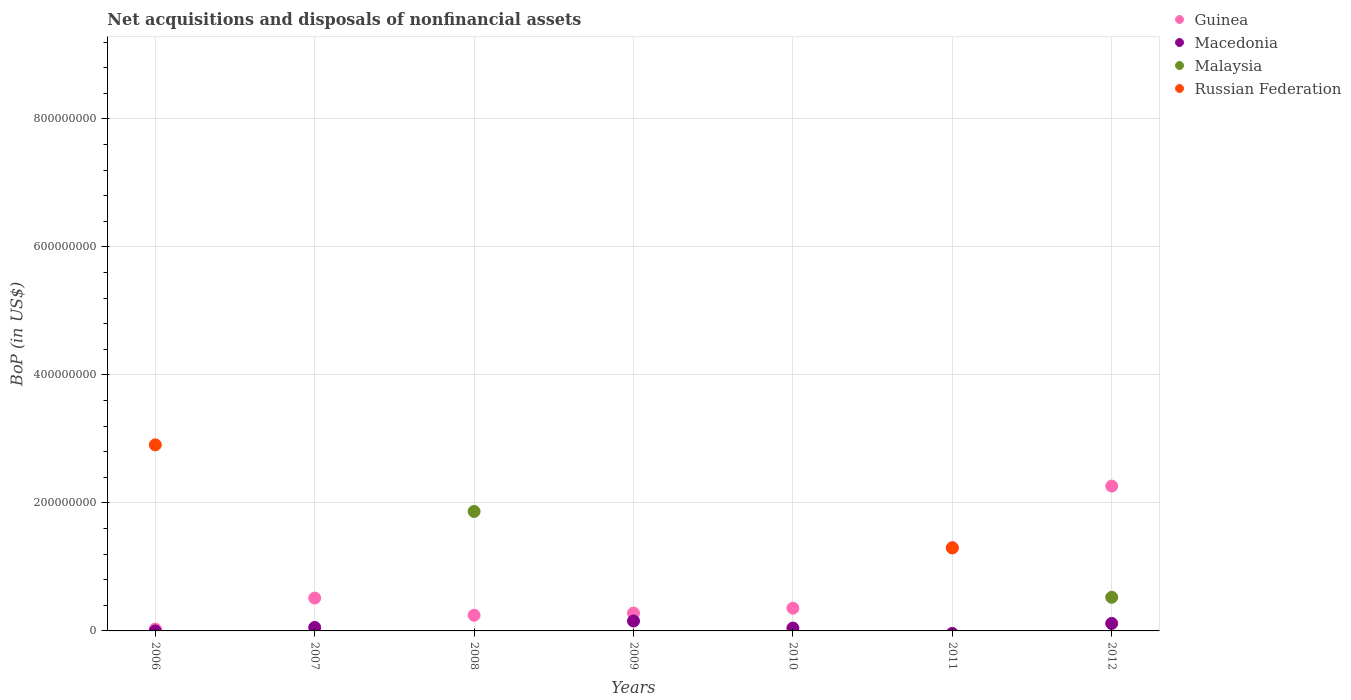How many different coloured dotlines are there?
Give a very brief answer. 4. What is the Balance of Payments in Guinea in 2006?
Your response must be concise. 2.83e+06. Across all years, what is the maximum Balance of Payments in Macedonia?
Make the answer very short. 1.55e+07. Across all years, what is the minimum Balance of Payments in Macedonia?
Offer a terse response. 0. In which year was the Balance of Payments in Macedonia maximum?
Your answer should be compact. 2009. What is the total Balance of Payments in Russian Federation in the graph?
Your answer should be very brief. 4.20e+08. What is the difference between the Balance of Payments in Macedonia in 2009 and that in 2010?
Make the answer very short. 1.10e+07. What is the difference between the Balance of Payments in Russian Federation in 2012 and the Balance of Payments in Guinea in 2008?
Provide a short and direct response. -2.45e+07. What is the average Balance of Payments in Russian Federation per year?
Make the answer very short. 6.01e+07. In the year 2009, what is the difference between the Balance of Payments in Guinea and Balance of Payments in Macedonia?
Your answer should be very brief. 1.24e+07. What is the ratio of the Balance of Payments in Macedonia in 2007 to that in 2010?
Your answer should be very brief. 1.2. Is the Balance of Payments in Guinea in 2006 less than that in 2007?
Ensure brevity in your answer.  Yes. What is the difference between the highest and the second highest Balance of Payments in Macedonia?
Your answer should be compact. 3.81e+06. What is the difference between the highest and the lowest Balance of Payments in Macedonia?
Make the answer very short. 1.55e+07. Is the sum of the Balance of Payments in Guinea in 2007 and 2009 greater than the maximum Balance of Payments in Russian Federation across all years?
Provide a short and direct response. No. Is it the case that in every year, the sum of the Balance of Payments in Russian Federation and Balance of Payments in Macedonia  is greater than the sum of Balance of Payments in Guinea and Balance of Payments in Malaysia?
Offer a terse response. No. Does the Balance of Payments in Guinea monotonically increase over the years?
Your answer should be very brief. No. Is the Balance of Payments in Macedonia strictly greater than the Balance of Payments in Russian Federation over the years?
Offer a very short reply. No. Is the Balance of Payments in Russian Federation strictly less than the Balance of Payments in Malaysia over the years?
Provide a short and direct response. No. Are the values on the major ticks of Y-axis written in scientific E-notation?
Provide a succinct answer. No. Does the graph contain any zero values?
Offer a very short reply. Yes. Does the graph contain grids?
Provide a short and direct response. Yes. Where does the legend appear in the graph?
Give a very brief answer. Top right. How many legend labels are there?
Ensure brevity in your answer.  4. What is the title of the graph?
Make the answer very short. Net acquisitions and disposals of nonfinancial assets. Does "St. Vincent and the Grenadines" appear as one of the legend labels in the graph?
Provide a short and direct response. No. What is the label or title of the Y-axis?
Keep it short and to the point. BoP (in US$). What is the BoP (in US$) of Guinea in 2006?
Your answer should be compact. 2.83e+06. What is the BoP (in US$) of Macedonia in 2006?
Give a very brief answer. 4585.23. What is the BoP (in US$) of Malaysia in 2006?
Ensure brevity in your answer.  0. What is the BoP (in US$) of Russian Federation in 2006?
Give a very brief answer. 2.91e+08. What is the BoP (in US$) of Guinea in 2007?
Your response must be concise. 5.13e+07. What is the BoP (in US$) in Macedonia in 2007?
Offer a very short reply. 5.40e+06. What is the BoP (in US$) of Guinea in 2008?
Offer a terse response. 2.45e+07. What is the BoP (in US$) of Malaysia in 2008?
Offer a very short reply. 1.87e+08. What is the BoP (in US$) of Guinea in 2009?
Make the answer very short. 2.79e+07. What is the BoP (in US$) of Macedonia in 2009?
Offer a terse response. 1.55e+07. What is the BoP (in US$) in Guinea in 2010?
Your answer should be very brief. 3.56e+07. What is the BoP (in US$) of Macedonia in 2010?
Your answer should be compact. 4.49e+06. What is the BoP (in US$) in Malaysia in 2010?
Ensure brevity in your answer.  0. What is the BoP (in US$) in Russian Federation in 2010?
Provide a short and direct response. 0. What is the BoP (in US$) in Guinea in 2011?
Make the answer very short. 1.30e+08. What is the BoP (in US$) in Malaysia in 2011?
Give a very brief answer. 0. What is the BoP (in US$) in Russian Federation in 2011?
Make the answer very short. 1.30e+08. What is the BoP (in US$) in Guinea in 2012?
Your answer should be compact. 2.26e+08. What is the BoP (in US$) of Macedonia in 2012?
Your answer should be compact. 1.17e+07. What is the BoP (in US$) of Malaysia in 2012?
Give a very brief answer. 5.25e+07. What is the BoP (in US$) in Russian Federation in 2012?
Your answer should be very brief. 0. Across all years, what is the maximum BoP (in US$) in Guinea?
Make the answer very short. 2.26e+08. Across all years, what is the maximum BoP (in US$) in Macedonia?
Make the answer very short. 1.55e+07. Across all years, what is the maximum BoP (in US$) in Malaysia?
Keep it short and to the point. 1.87e+08. Across all years, what is the maximum BoP (in US$) of Russian Federation?
Offer a terse response. 2.91e+08. Across all years, what is the minimum BoP (in US$) of Guinea?
Your answer should be compact. 2.83e+06. Across all years, what is the minimum BoP (in US$) of Macedonia?
Your answer should be compact. 0. Across all years, what is the minimum BoP (in US$) of Malaysia?
Make the answer very short. 0. Across all years, what is the minimum BoP (in US$) in Russian Federation?
Offer a terse response. 0. What is the total BoP (in US$) in Guinea in the graph?
Keep it short and to the point. 4.98e+08. What is the total BoP (in US$) in Macedonia in the graph?
Ensure brevity in your answer.  3.71e+07. What is the total BoP (in US$) in Malaysia in the graph?
Ensure brevity in your answer.  2.39e+08. What is the total BoP (in US$) in Russian Federation in the graph?
Provide a succinct answer. 4.20e+08. What is the difference between the BoP (in US$) of Guinea in 2006 and that in 2007?
Offer a very short reply. -4.85e+07. What is the difference between the BoP (in US$) of Macedonia in 2006 and that in 2007?
Your response must be concise. -5.40e+06. What is the difference between the BoP (in US$) of Guinea in 2006 and that in 2008?
Ensure brevity in your answer.  -2.16e+07. What is the difference between the BoP (in US$) in Guinea in 2006 and that in 2009?
Your response must be concise. -2.50e+07. What is the difference between the BoP (in US$) of Macedonia in 2006 and that in 2009?
Make the answer very short. -1.55e+07. What is the difference between the BoP (in US$) in Guinea in 2006 and that in 2010?
Your answer should be compact. -3.27e+07. What is the difference between the BoP (in US$) in Macedonia in 2006 and that in 2010?
Keep it short and to the point. -4.48e+06. What is the difference between the BoP (in US$) of Guinea in 2006 and that in 2011?
Ensure brevity in your answer.  -1.27e+08. What is the difference between the BoP (in US$) in Russian Federation in 2006 and that in 2011?
Your response must be concise. 1.61e+08. What is the difference between the BoP (in US$) in Guinea in 2006 and that in 2012?
Your answer should be compact. -2.23e+08. What is the difference between the BoP (in US$) in Macedonia in 2006 and that in 2012?
Ensure brevity in your answer.  -1.17e+07. What is the difference between the BoP (in US$) in Guinea in 2007 and that in 2008?
Give a very brief answer. 2.68e+07. What is the difference between the BoP (in US$) of Guinea in 2007 and that in 2009?
Offer a terse response. 2.34e+07. What is the difference between the BoP (in US$) of Macedonia in 2007 and that in 2009?
Offer a terse response. -1.01e+07. What is the difference between the BoP (in US$) of Guinea in 2007 and that in 2010?
Provide a short and direct response. 1.58e+07. What is the difference between the BoP (in US$) in Macedonia in 2007 and that in 2010?
Ensure brevity in your answer.  9.14e+05. What is the difference between the BoP (in US$) in Guinea in 2007 and that in 2011?
Your response must be concise. -7.87e+07. What is the difference between the BoP (in US$) in Guinea in 2007 and that in 2012?
Your answer should be compact. -1.75e+08. What is the difference between the BoP (in US$) of Macedonia in 2007 and that in 2012?
Provide a succinct answer. -6.30e+06. What is the difference between the BoP (in US$) of Guinea in 2008 and that in 2009?
Make the answer very short. -3.39e+06. What is the difference between the BoP (in US$) of Guinea in 2008 and that in 2010?
Provide a short and direct response. -1.11e+07. What is the difference between the BoP (in US$) in Guinea in 2008 and that in 2011?
Ensure brevity in your answer.  -1.06e+08. What is the difference between the BoP (in US$) in Guinea in 2008 and that in 2012?
Offer a terse response. -2.02e+08. What is the difference between the BoP (in US$) in Malaysia in 2008 and that in 2012?
Give a very brief answer. 1.34e+08. What is the difference between the BoP (in US$) in Guinea in 2009 and that in 2010?
Make the answer very short. -7.70e+06. What is the difference between the BoP (in US$) in Macedonia in 2009 and that in 2010?
Offer a terse response. 1.10e+07. What is the difference between the BoP (in US$) in Guinea in 2009 and that in 2011?
Offer a terse response. -1.02e+08. What is the difference between the BoP (in US$) of Guinea in 2009 and that in 2012?
Ensure brevity in your answer.  -1.98e+08. What is the difference between the BoP (in US$) in Macedonia in 2009 and that in 2012?
Offer a very short reply. 3.81e+06. What is the difference between the BoP (in US$) in Guinea in 2010 and that in 2011?
Your answer should be compact. -9.45e+07. What is the difference between the BoP (in US$) of Guinea in 2010 and that in 2012?
Offer a very short reply. -1.91e+08. What is the difference between the BoP (in US$) in Macedonia in 2010 and that in 2012?
Give a very brief answer. -7.22e+06. What is the difference between the BoP (in US$) in Guinea in 2011 and that in 2012?
Ensure brevity in your answer.  -9.62e+07. What is the difference between the BoP (in US$) in Guinea in 2006 and the BoP (in US$) in Macedonia in 2007?
Give a very brief answer. -2.57e+06. What is the difference between the BoP (in US$) of Guinea in 2006 and the BoP (in US$) of Malaysia in 2008?
Offer a terse response. -1.84e+08. What is the difference between the BoP (in US$) in Macedonia in 2006 and the BoP (in US$) in Malaysia in 2008?
Your response must be concise. -1.87e+08. What is the difference between the BoP (in US$) in Guinea in 2006 and the BoP (in US$) in Macedonia in 2009?
Your response must be concise. -1.27e+07. What is the difference between the BoP (in US$) in Guinea in 2006 and the BoP (in US$) in Macedonia in 2010?
Give a very brief answer. -1.66e+06. What is the difference between the BoP (in US$) of Guinea in 2006 and the BoP (in US$) of Russian Federation in 2011?
Offer a very short reply. -1.27e+08. What is the difference between the BoP (in US$) of Macedonia in 2006 and the BoP (in US$) of Russian Federation in 2011?
Provide a short and direct response. -1.30e+08. What is the difference between the BoP (in US$) in Guinea in 2006 and the BoP (in US$) in Macedonia in 2012?
Provide a short and direct response. -8.87e+06. What is the difference between the BoP (in US$) of Guinea in 2006 and the BoP (in US$) of Malaysia in 2012?
Your answer should be very brief. -4.97e+07. What is the difference between the BoP (in US$) of Macedonia in 2006 and the BoP (in US$) of Malaysia in 2012?
Give a very brief answer. -5.25e+07. What is the difference between the BoP (in US$) in Guinea in 2007 and the BoP (in US$) in Malaysia in 2008?
Your answer should be compact. -1.35e+08. What is the difference between the BoP (in US$) in Macedonia in 2007 and the BoP (in US$) in Malaysia in 2008?
Provide a short and direct response. -1.81e+08. What is the difference between the BoP (in US$) of Guinea in 2007 and the BoP (in US$) of Macedonia in 2009?
Keep it short and to the point. 3.58e+07. What is the difference between the BoP (in US$) in Guinea in 2007 and the BoP (in US$) in Macedonia in 2010?
Your answer should be compact. 4.68e+07. What is the difference between the BoP (in US$) of Guinea in 2007 and the BoP (in US$) of Russian Federation in 2011?
Provide a short and direct response. -7.84e+07. What is the difference between the BoP (in US$) of Macedonia in 2007 and the BoP (in US$) of Russian Federation in 2011?
Your answer should be compact. -1.24e+08. What is the difference between the BoP (in US$) of Guinea in 2007 and the BoP (in US$) of Macedonia in 2012?
Your answer should be compact. 3.96e+07. What is the difference between the BoP (in US$) of Guinea in 2007 and the BoP (in US$) of Malaysia in 2012?
Offer a very short reply. -1.22e+06. What is the difference between the BoP (in US$) in Macedonia in 2007 and the BoP (in US$) in Malaysia in 2012?
Provide a succinct answer. -4.71e+07. What is the difference between the BoP (in US$) in Guinea in 2008 and the BoP (in US$) in Macedonia in 2009?
Your answer should be very brief. 8.97e+06. What is the difference between the BoP (in US$) of Guinea in 2008 and the BoP (in US$) of Macedonia in 2010?
Provide a short and direct response. 2.00e+07. What is the difference between the BoP (in US$) of Guinea in 2008 and the BoP (in US$) of Russian Federation in 2011?
Give a very brief answer. -1.05e+08. What is the difference between the BoP (in US$) of Malaysia in 2008 and the BoP (in US$) of Russian Federation in 2011?
Offer a terse response. 5.69e+07. What is the difference between the BoP (in US$) in Guinea in 2008 and the BoP (in US$) in Macedonia in 2012?
Provide a succinct answer. 1.28e+07. What is the difference between the BoP (in US$) in Guinea in 2008 and the BoP (in US$) in Malaysia in 2012?
Offer a very short reply. -2.81e+07. What is the difference between the BoP (in US$) in Guinea in 2009 and the BoP (in US$) in Macedonia in 2010?
Your response must be concise. 2.34e+07. What is the difference between the BoP (in US$) in Guinea in 2009 and the BoP (in US$) in Russian Federation in 2011?
Your answer should be compact. -1.02e+08. What is the difference between the BoP (in US$) in Macedonia in 2009 and the BoP (in US$) in Russian Federation in 2011?
Make the answer very short. -1.14e+08. What is the difference between the BoP (in US$) of Guinea in 2009 and the BoP (in US$) of Macedonia in 2012?
Your answer should be very brief. 1.62e+07. What is the difference between the BoP (in US$) of Guinea in 2009 and the BoP (in US$) of Malaysia in 2012?
Offer a terse response. -2.47e+07. What is the difference between the BoP (in US$) in Macedonia in 2009 and the BoP (in US$) in Malaysia in 2012?
Offer a very short reply. -3.70e+07. What is the difference between the BoP (in US$) of Guinea in 2010 and the BoP (in US$) of Russian Federation in 2011?
Offer a terse response. -9.41e+07. What is the difference between the BoP (in US$) of Macedonia in 2010 and the BoP (in US$) of Russian Federation in 2011?
Provide a short and direct response. -1.25e+08. What is the difference between the BoP (in US$) in Guinea in 2010 and the BoP (in US$) in Macedonia in 2012?
Provide a short and direct response. 2.39e+07. What is the difference between the BoP (in US$) of Guinea in 2010 and the BoP (in US$) of Malaysia in 2012?
Provide a short and direct response. -1.70e+07. What is the difference between the BoP (in US$) of Macedonia in 2010 and the BoP (in US$) of Malaysia in 2012?
Ensure brevity in your answer.  -4.81e+07. What is the difference between the BoP (in US$) of Guinea in 2011 and the BoP (in US$) of Macedonia in 2012?
Your answer should be compact. 1.18e+08. What is the difference between the BoP (in US$) in Guinea in 2011 and the BoP (in US$) in Malaysia in 2012?
Your response must be concise. 7.75e+07. What is the average BoP (in US$) of Guinea per year?
Offer a very short reply. 7.12e+07. What is the average BoP (in US$) in Macedonia per year?
Offer a terse response. 5.30e+06. What is the average BoP (in US$) of Malaysia per year?
Give a very brief answer. 3.42e+07. What is the average BoP (in US$) in Russian Federation per year?
Keep it short and to the point. 6.01e+07. In the year 2006, what is the difference between the BoP (in US$) in Guinea and BoP (in US$) in Macedonia?
Ensure brevity in your answer.  2.83e+06. In the year 2006, what is the difference between the BoP (in US$) in Guinea and BoP (in US$) in Russian Federation?
Your answer should be compact. -2.88e+08. In the year 2006, what is the difference between the BoP (in US$) of Macedonia and BoP (in US$) of Russian Federation?
Give a very brief answer. -2.91e+08. In the year 2007, what is the difference between the BoP (in US$) of Guinea and BoP (in US$) of Macedonia?
Your response must be concise. 4.59e+07. In the year 2008, what is the difference between the BoP (in US$) of Guinea and BoP (in US$) of Malaysia?
Your answer should be compact. -1.62e+08. In the year 2009, what is the difference between the BoP (in US$) in Guinea and BoP (in US$) in Macedonia?
Your response must be concise. 1.24e+07. In the year 2010, what is the difference between the BoP (in US$) in Guinea and BoP (in US$) in Macedonia?
Your answer should be compact. 3.11e+07. In the year 2011, what is the difference between the BoP (in US$) in Guinea and BoP (in US$) in Russian Federation?
Your response must be concise. 3.38e+05. In the year 2012, what is the difference between the BoP (in US$) in Guinea and BoP (in US$) in Macedonia?
Your answer should be very brief. 2.15e+08. In the year 2012, what is the difference between the BoP (in US$) of Guinea and BoP (in US$) of Malaysia?
Keep it short and to the point. 1.74e+08. In the year 2012, what is the difference between the BoP (in US$) in Macedonia and BoP (in US$) in Malaysia?
Offer a very short reply. -4.08e+07. What is the ratio of the BoP (in US$) of Guinea in 2006 to that in 2007?
Offer a very short reply. 0.06. What is the ratio of the BoP (in US$) in Macedonia in 2006 to that in 2007?
Your answer should be compact. 0. What is the ratio of the BoP (in US$) in Guinea in 2006 to that in 2008?
Offer a very short reply. 0.12. What is the ratio of the BoP (in US$) of Guinea in 2006 to that in 2009?
Provide a succinct answer. 0.1. What is the ratio of the BoP (in US$) in Guinea in 2006 to that in 2010?
Your answer should be compact. 0.08. What is the ratio of the BoP (in US$) in Macedonia in 2006 to that in 2010?
Provide a succinct answer. 0. What is the ratio of the BoP (in US$) of Guinea in 2006 to that in 2011?
Give a very brief answer. 0.02. What is the ratio of the BoP (in US$) of Russian Federation in 2006 to that in 2011?
Make the answer very short. 2.24. What is the ratio of the BoP (in US$) in Guinea in 2006 to that in 2012?
Offer a terse response. 0.01. What is the ratio of the BoP (in US$) in Macedonia in 2006 to that in 2012?
Your response must be concise. 0. What is the ratio of the BoP (in US$) of Guinea in 2007 to that in 2008?
Make the answer very short. 2.1. What is the ratio of the BoP (in US$) of Guinea in 2007 to that in 2009?
Your response must be concise. 1.84. What is the ratio of the BoP (in US$) of Macedonia in 2007 to that in 2009?
Your answer should be very brief. 0.35. What is the ratio of the BoP (in US$) of Guinea in 2007 to that in 2010?
Your answer should be compact. 1.44. What is the ratio of the BoP (in US$) of Macedonia in 2007 to that in 2010?
Give a very brief answer. 1.2. What is the ratio of the BoP (in US$) of Guinea in 2007 to that in 2011?
Offer a very short reply. 0.39. What is the ratio of the BoP (in US$) of Guinea in 2007 to that in 2012?
Keep it short and to the point. 0.23. What is the ratio of the BoP (in US$) in Macedonia in 2007 to that in 2012?
Keep it short and to the point. 0.46. What is the ratio of the BoP (in US$) in Guinea in 2008 to that in 2009?
Give a very brief answer. 0.88. What is the ratio of the BoP (in US$) in Guinea in 2008 to that in 2010?
Provide a short and direct response. 0.69. What is the ratio of the BoP (in US$) of Guinea in 2008 to that in 2011?
Keep it short and to the point. 0.19. What is the ratio of the BoP (in US$) in Guinea in 2008 to that in 2012?
Make the answer very short. 0.11. What is the ratio of the BoP (in US$) of Malaysia in 2008 to that in 2012?
Your answer should be compact. 3.55. What is the ratio of the BoP (in US$) in Guinea in 2009 to that in 2010?
Your answer should be very brief. 0.78. What is the ratio of the BoP (in US$) of Macedonia in 2009 to that in 2010?
Your answer should be compact. 3.46. What is the ratio of the BoP (in US$) of Guinea in 2009 to that in 2011?
Keep it short and to the point. 0.21. What is the ratio of the BoP (in US$) of Guinea in 2009 to that in 2012?
Give a very brief answer. 0.12. What is the ratio of the BoP (in US$) in Macedonia in 2009 to that in 2012?
Provide a succinct answer. 1.33. What is the ratio of the BoP (in US$) in Guinea in 2010 to that in 2011?
Give a very brief answer. 0.27. What is the ratio of the BoP (in US$) in Guinea in 2010 to that in 2012?
Make the answer very short. 0.16. What is the ratio of the BoP (in US$) of Macedonia in 2010 to that in 2012?
Offer a very short reply. 0.38. What is the ratio of the BoP (in US$) in Guinea in 2011 to that in 2012?
Keep it short and to the point. 0.57. What is the difference between the highest and the second highest BoP (in US$) in Guinea?
Keep it short and to the point. 9.62e+07. What is the difference between the highest and the second highest BoP (in US$) of Macedonia?
Your answer should be compact. 3.81e+06. What is the difference between the highest and the lowest BoP (in US$) in Guinea?
Offer a very short reply. 2.23e+08. What is the difference between the highest and the lowest BoP (in US$) in Macedonia?
Offer a very short reply. 1.55e+07. What is the difference between the highest and the lowest BoP (in US$) in Malaysia?
Offer a very short reply. 1.87e+08. What is the difference between the highest and the lowest BoP (in US$) in Russian Federation?
Make the answer very short. 2.91e+08. 